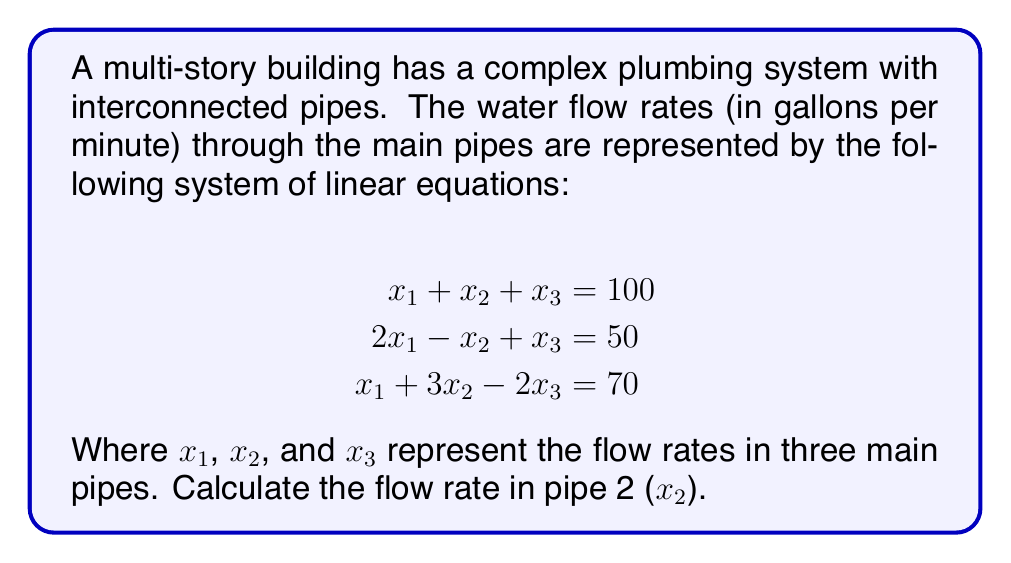Can you solve this math problem? To solve this system of linear equations, we'll use the Gaussian elimination method:

Step 1: Write the augmented matrix
$$\begin{bmatrix}
1 & 1 & 1 & 100 \\
2 & -1 & 1 & 50 \\
1 & 3 & -2 & 70
\end{bmatrix}$$

Step 2: Eliminate $x_1$ from the second equation
Multiply row 1 by -2 and add to row 2:
$$\begin{bmatrix}
1 & 1 & 1 & 100 \\
0 & -3 & -1 & -150 \\
1 & 3 & -2 & 70
\end{bmatrix}$$

Step 3: Eliminate $x_1$ from the third equation
Subtract row 1 from row 3:
$$\begin{bmatrix}
1 & 1 & 1 & 100 \\
0 & -3 & -1 & -150 \\
0 & 2 & -3 & -30
\end{bmatrix}$$

Step 4: Eliminate $x_2$ from the third equation
Multiply row 2 by 2/3 and add to row 3:
$$\begin{bmatrix}
1 & 1 & 1 & 100 \\
0 & -3 & -1 & -150 \\
0 & 0 & -3.67 & -130
\end{bmatrix}$$

Step 5: Solve for $x_3$
$-3.67x_3 = -130$
$x_3 = 35.42$

Step 6: Substitute $x_3$ into the second equation
$-3x_2 - 35.42 = -150$
$-3x_2 = -114.58$
$x_2 = 38.19$

Therefore, the flow rate in pipe 2 ($x_2$) is approximately 38.19 gallons per minute.
Answer: 38.19 gallons per minute 